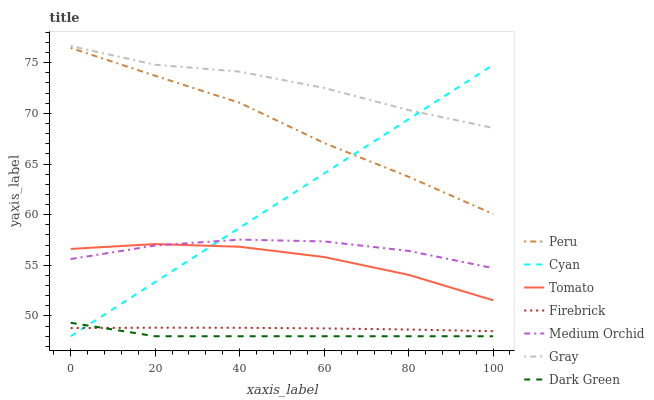Does Dark Green have the minimum area under the curve?
Answer yes or no. Yes. Does Gray have the maximum area under the curve?
Answer yes or no. Yes. Does Firebrick have the minimum area under the curve?
Answer yes or no. No. Does Firebrick have the maximum area under the curve?
Answer yes or no. No. Is Cyan the smoothest?
Answer yes or no. Yes. Is Gray the roughest?
Answer yes or no. Yes. Is Firebrick the smoothest?
Answer yes or no. No. Is Firebrick the roughest?
Answer yes or no. No. Does Firebrick have the lowest value?
Answer yes or no. No. Does Gray have the highest value?
Answer yes or no. Yes. Does Firebrick have the highest value?
Answer yes or no. No. Is Tomato less than Gray?
Answer yes or no. Yes. Is Medium Orchid greater than Firebrick?
Answer yes or no. Yes. Does Tomato intersect Gray?
Answer yes or no. No. 